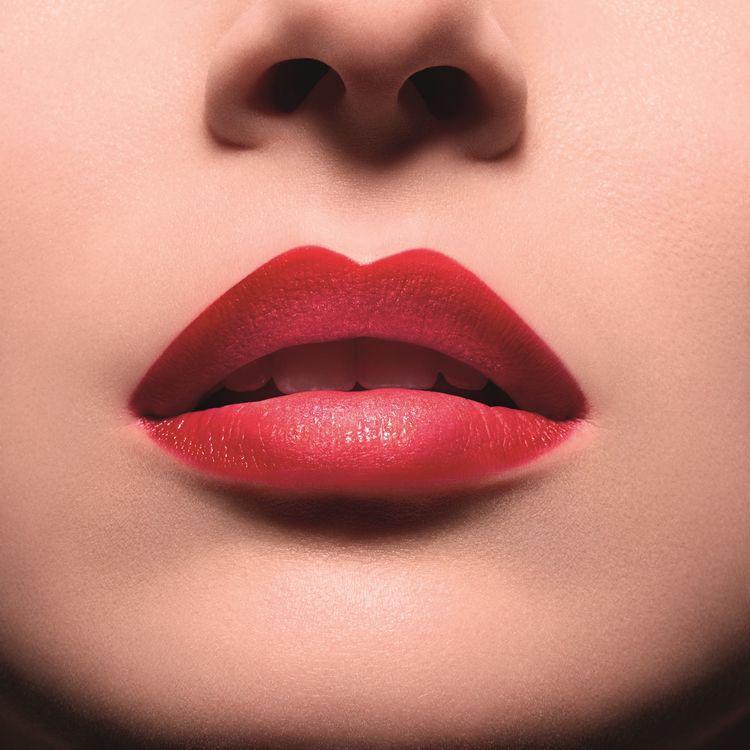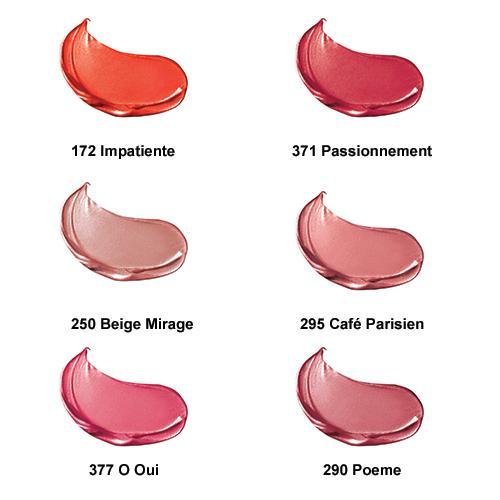The first image is the image on the left, the second image is the image on the right. Given the left and right images, does the statement "There are 6 shades of lipstick presented in the image on the right." hold true? Answer yes or no. Yes. The first image is the image on the left, the second image is the image on the right. Considering the images on both sides, is "One image shows exactly six different lipstick color samples." valid? Answer yes or no. Yes. 